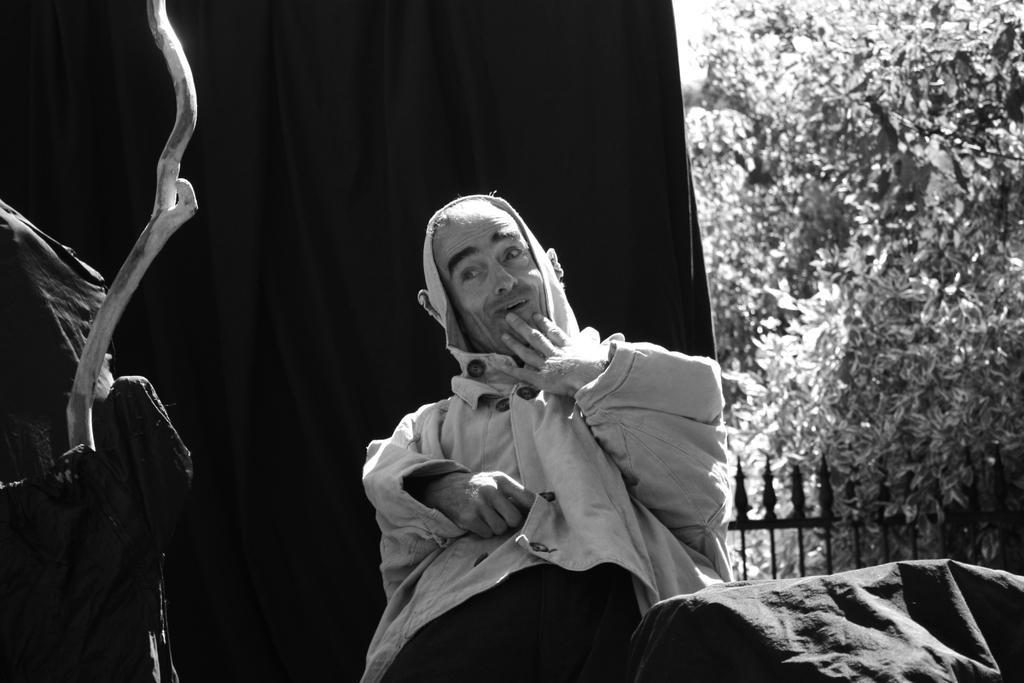Can you describe this image briefly? This is a black and white picture. In this picture we can see a tree, fence. We can see a man wearing a hoodie, behind to him we can see a curtain and beside to him we can see a branch and a black cloth. 